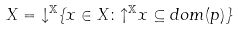<formula> <loc_0><loc_0><loc_500><loc_500>X = { \downarrow } ^ { \mathbb { X } } \{ x \in X \colon { \uparrow } ^ { \mathbb { X } } x \subseteq d o m ( p ) \}</formula> 